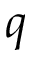<formula> <loc_0><loc_0><loc_500><loc_500>q</formula> 